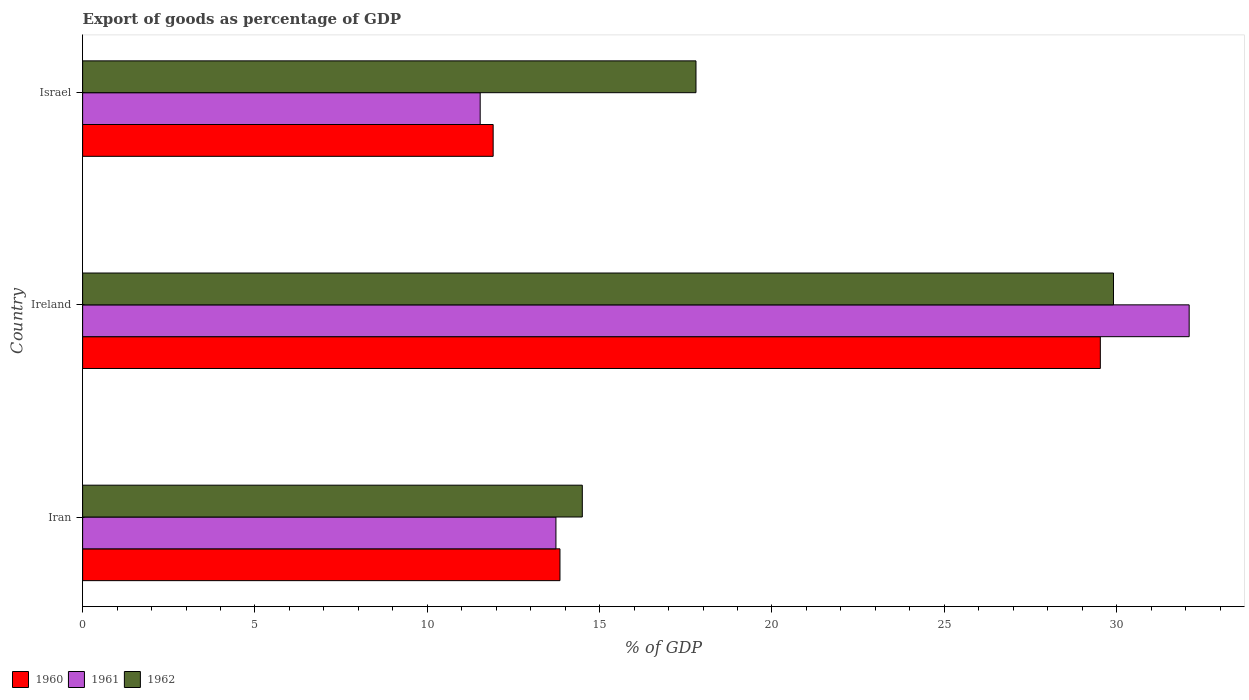How many different coloured bars are there?
Keep it short and to the point. 3. How many groups of bars are there?
Make the answer very short. 3. Are the number of bars on each tick of the Y-axis equal?
Make the answer very short. Yes. How many bars are there on the 1st tick from the bottom?
Provide a succinct answer. 3. What is the label of the 3rd group of bars from the top?
Your answer should be very brief. Iran. What is the export of goods as percentage of GDP in 1960 in Israel?
Make the answer very short. 11.91. Across all countries, what is the maximum export of goods as percentage of GDP in 1962?
Offer a very short reply. 29.91. Across all countries, what is the minimum export of goods as percentage of GDP in 1960?
Ensure brevity in your answer.  11.91. In which country was the export of goods as percentage of GDP in 1961 maximum?
Offer a terse response. Ireland. What is the total export of goods as percentage of GDP in 1962 in the graph?
Keep it short and to the point. 62.2. What is the difference between the export of goods as percentage of GDP in 1962 in Iran and that in Israel?
Your answer should be compact. -3.3. What is the difference between the export of goods as percentage of GDP in 1960 in Israel and the export of goods as percentage of GDP in 1962 in Iran?
Your answer should be very brief. -2.59. What is the average export of goods as percentage of GDP in 1960 per country?
Your answer should be compact. 18.43. What is the difference between the export of goods as percentage of GDP in 1960 and export of goods as percentage of GDP in 1961 in Ireland?
Provide a succinct answer. -2.58. In how many countries, is the export of goods as percentage of GDP in 1962 greater than 27 %?
Make the answer very short. 1. What is the ratio of the export of goods as percentage of GDP in 1961 in Iran to that in Ireland?
Offer a very short reply. 0.43. Is the export of goods as percentage of GDP in 1962 in Iran less than that in Ireland?
Provide a succinct answer. Yes. What is the difference between the highest and the second highest export of goods as percentage of GDP in 1961?
Your answer should be compact. 18.37. What is the difference between the highest and the lowest export of goods as percentage of GDP in 1960?
Your response must be concise. 17.62. In how many countries, is the export of goods as percentage of GDP in 1960 greater than the average export of goods as percentage of GDP in 1960 taken over all countries?
Give a very brief answer. 1. What does the 3rd bar from the top in Iran represents?
Your answer should be compact. 1960. What does the 1st bar from the bottom in Ireland represents?
Your response must be concise. 1960. Is it the case that in every country, the sum of the export of goods as percentage of GDP in 1960 and export of goods as percentage of GDP in 1962 is greater than the export of goods as percentage of GDP in 1961?
Your response must be concise. Yes. How many bars are there?
Your response must be concise. 9. Are all the bars in the graph horizontal?
Your response must be concise. Yes. How many countries are there in the graph?
Ensure brevity in your answer.  3. Are the values on the major ticks of X-axis written in scientific E-notation?
Offer a terse response. No. Does the graph contain any zero values?
Offer a terse response. No. Does the graph contain grids?
Ensure brevity in your answer.  No. How are the legend labels stacked?
Provide a succinct answer. Horizontal. What is the title of the graph?
Offer a terse response. Export of goods as percentage of GDP. What is the label or title of the X-axis?
Your response must be concise. % of GDP. What is the label or title of the Y-axis?
Your answer should be compact. Country. What is the % of GDP of 1960 in Iran?
Ensure brevity in your answer.  13.85. What is the % of GDP of 1961 in Iran?
Your answer should be very brief. 13.73. What is the % of GDP in 1962 in Iran?
Ensure brevity in your answer.  14.5. What is the % of GDP in 1960 in Ireland?
Your answer should be very brief. 29.53. What is the % of GDP in 1961 in Ireland?
Provide a short and direct response. 32.1. What is the % of GDP of 1962 in Ireland?
Provide a succinct answer. 29.91. What is the % of GDP in 1960 in Israel?
Make the answer very short. 11.91. What is the % of GDP of 1961 in Israel?
Your response must be concise. 11.53. What is the % of GDP of 1962 in Israel?
Offer a very short reply. 17.8. Across all countries, what is the maximum % of GDP in 1960?
Give a very brief answer. 29.53. Across all countries, what is the maximum % of GDP of 1961?
Give a very brief answer. 32.1. Across all countries, what is the maximum % of GDP in 1962?
Provide a short and direct response. 29.91. Across all countries, what is the minimum % of GDP in 1960?
Offer a terse response. 11.91. Across all countries, what is the minimum % of GDP of 1961?
Your answer should be compact. 11.53. Across all countries, what is the minimum % of GDP of 1962?
Your response must be concise. 14.5. What is the total % of GDP in 1960 in the graph?
Provide a succinct answer. 55.29. What is the total % of GDP of 1961 in the graph?
Ensure brevity in your answer.  57.37. What is the total % of GDP in 1962 in the graph?
Your answer should be compact. 62.2. What is the difference between the % of GDP of 1960 in Iran and that in Ireland?
Provide a succinct answer. -15.68. What is the difference between the % of GDP in 1961 in Iran and that in Ireland?
Provide a succinct answer. -18.37. What is the difference between the % of GDP of 1962 in Iran and that in Ireland?
Provide a succinct answer. -15.41. What is the difference between the % of GDP in 1960 in Iran and that in Israel?
Provide a succinct answer. 1.94. What is the difference between the % of GDP in 1961 in Iran and that in Israel?
Provide a short and direct response. 2.2. What is the difference between the % of GDP of 1962 in Iran and that in Israel?
Your answer should be compact. -3.3. What is the difference between the % of GDP in 1960 in Ireland and that in Israel?
Give a very brief answer. 17.62. What is the difference between the % of GDP of 1961 in Ireland and that in Israel?
Provide a succinct answer. 20.57. What is the difference between the % of GDP of 1962 in Ireland and that in Israel?
Your answer should be compact. 12.11. What is the difference between the % of GDP in 1960 in Iran and the % of GDP in 1961 in Ireland?
Your response must be concise. -18.25. What is the difference between the % of GDP of 1960 in Iran and the % of GDP of 1962 in Ireland?
Your answer should be very brief. -16.06. What is the difference between the % of GDP of 1961 in Iran and the % of GDP of 1962 in Ireland?
Your answer should be very brief. -16.18. What is the difference between the % of GDP in 1960 in Iran and the % of GDP in 1961 in Israel?
Your response must be concise. 2.31. What is the difference between the % of GDP of 1960 in Iran and the % of GDP of 1962 in Israel?
Your response must be concise. -3.95. What is the difference between the % of GDP in 1961 in Iran and the % of GDP in 1962 in Israel?
Keep it short and to the point. -4.06. What is the difference between the % of GDP in 1960 in Ireland and the % of GDP in 1961 in Israel?
Offer a very short reply. 17.99. What is the difference between the % of GDP of 1960 in Ireland and the % of GDP of 1962 in Israel?
Offer a terse response. 11.73. What is the difference between the % of GDP of 1961 in Ireland and the % of GDP of 1962 in Israel?
Offer a terse response. 14.31. What is the average % of GDP in 1960 per country?
Offer a very short reply. 18.43. What is the average % of GDP in 1961 per country?
Offer a very short reply. 19.12. What is the average % of GDP in 1962 per country?
Keep it short and to the point. 20.73. What is the difference between the % of GDP of 1960 and % of GDP of 1961 in Iran?
Your response must be concise. 0.12. What is the difference between the % of GDP in 1960 and % of GDP in 1962 in Iran?
Give a very brief answer. -0.65. What is the difference between the % of GDP in 1961 and % of GDP in 1962 in Iran?
Keep it short and to the point. -0.77. What is the difference between the % of GDP of 1960 and % of GDP of 1961 in Ireland?
Ensure brevity in your answer.  -2.58. What is the difference between the % of GDP of 1960 and % of GDP of 1962 in Ireland?
Make the answer very short. -0.38. What is the difference between the % of GDP of 1961 and % of GDP of 1962 in Ireland?
Your answer should be compact. 2.2. What is the difference between the % of GDP in 1960 and % of GDP in 1961 in Israel?
Your answer should be compact. 0.38. What is the difference between the % of GDP of 1960 and % of GDP of 1962 in Israel?
Offer a very short reply. -5.88. What is the difference between the % of GDP of 1961 and % of GDP of 1962 in Israel?
Provide a succinct answer. -6.26. What is the ratio of the % of GDP of 1960 in Iran to that in Ireland?
Give a very brief answer. 0.47. What is the ratio of the % of GDP in 1961 in Iran to that in Ireland?
Provide a short and direct response. 0.43. What is the ratio of the % of GDP of 1962 in Iran to that in Ireland?
Your response must be concise. 0.48. What is the ratio of the % of GDP of 1960 in Iran to that in Israel?
Provide a short and direct response. 1.16. What is the ratio of the % of GDP in 1961 in Iran to that in Israel?
Make the answer very short. 1.19. What is the ratio of the % of GDP in 1962 in Iran to that in Israel?
Keep it short and to the point. 0.81. What is the ratio of the % of GDP in 1960 in Ireland to that in Israel?
Give a very brief answer. 2.48. What is the ratio of the % of GDP of 1961 in Ireland to that in Israel?
Give a very brief answer. 2.78. What is the ratio of the % of GDP in 1962 in Ireland to that in Israel?
Your response must be concise. 1.68. What is the difference between the highest and the second highest % of GDP of 1960?
Provide a short and direct response. 15.68. What is the difference between the highest and the second highest % of GDP in 1961?
Give a very brief answer. 18.37. What is the difference between the highest and the second highest % of GDP of 1962?
Give a very brief answer. 12.11. What is the difference between the highest and the lowest % of GDP of 1960?
Provide a succinct answer. 17.62. What is the difference between the highest and the lowest % of GDP in 1961?
Offer a very short reply. 20.57. What is the difference between the highest and the lowest % of GDP of 1962?
Ensure brevity in your answer.  15.41. 